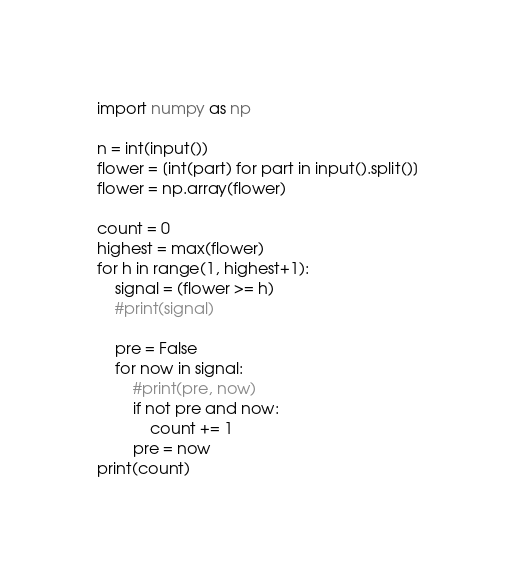<code> <loc_0><loc_0><loc_500><loc_500><_Python_>import numpy as np

n = int(input())
flower = [int(part) for part in input().split()]
flower = np.array(flower)

count = 0
highest = max(flower)
for h in range(1, highest+1):
    signal = (flower >= h)
    #print(signal)
    
    pre = False
    for now in signal:
        #print(pre, now)
        if not pre and now:
            count += 1
        pre = now
print(count)</code> 